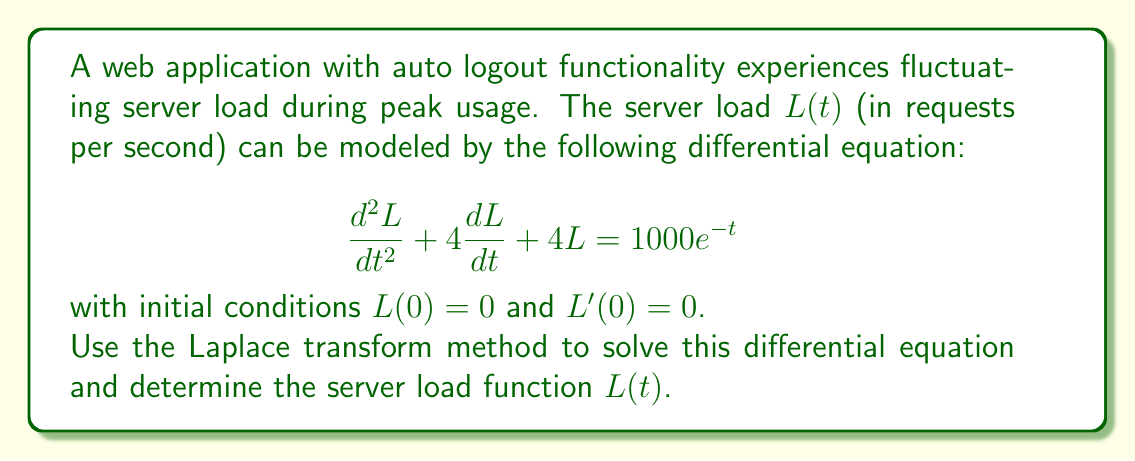Could you help me with this problem? Let's solve this step-by-step using the Laplace transform method:

1) First, let's take the Laplace transform of both sides of the equation. Let $\mathcal{L}\{L(t)\} = F(s)$.

   $$\mathcal{L}\{\frac{d^2L}{dt^2} + 4\frac{dL}{dt} + 4L\} = \mathcal{L}\{1000e^{-t}\}$$

2) Using Laplace transform properties:

   $$s^2F(s) - sL(0) - L'(0) + 4(sF(s) - L(0)) + 4F(s) = \frac{1000}{s+1}$$

3) Substituting the initial conditions $L(0) = 0$ and $L'(0) = 0$:

   $$s^2F(s) + 4sF(s) + 4F(s) = \frac{1000}{s+1}$$

4) Factoring out $F(s)$:

   $$F(s)(s^2 + 4s + 4) = \frac{1000}{s+1}$$

5) Solving for $F(s)$:

   $$F(s) = \frac{1000}{(s+1)(s^2 + 4s + 4)} = \frac{1000}{(s+1)(s+2)^2}$$

6) Now we need to find the inverse Laplace transform. We can use partial fraction decomposition:

   $$F(s) = \frac{A}{s+1} + \frac{B}{s+2} + \frac{C}{(s+2)^2}$$

7) Solving for $A$, $B$, and $C$:

   $$A = 250, B = -500, C = 250$$

8) Therefore:

   $$F(s) = \frac{250}{s+1} - \frac{500}{s+2} + \frac{250}{(s+2)^2}$$

9) Taking the inverse Laplace transform:

   $$L(t) = 250e^{-t} - 500e^{-2t} + 250te^{-2t}$$

This is the solution to the differential equation.
Answer: $L(t) = 250e^{-t} - 500e^{-2t} + 250te^{-2t}$ 